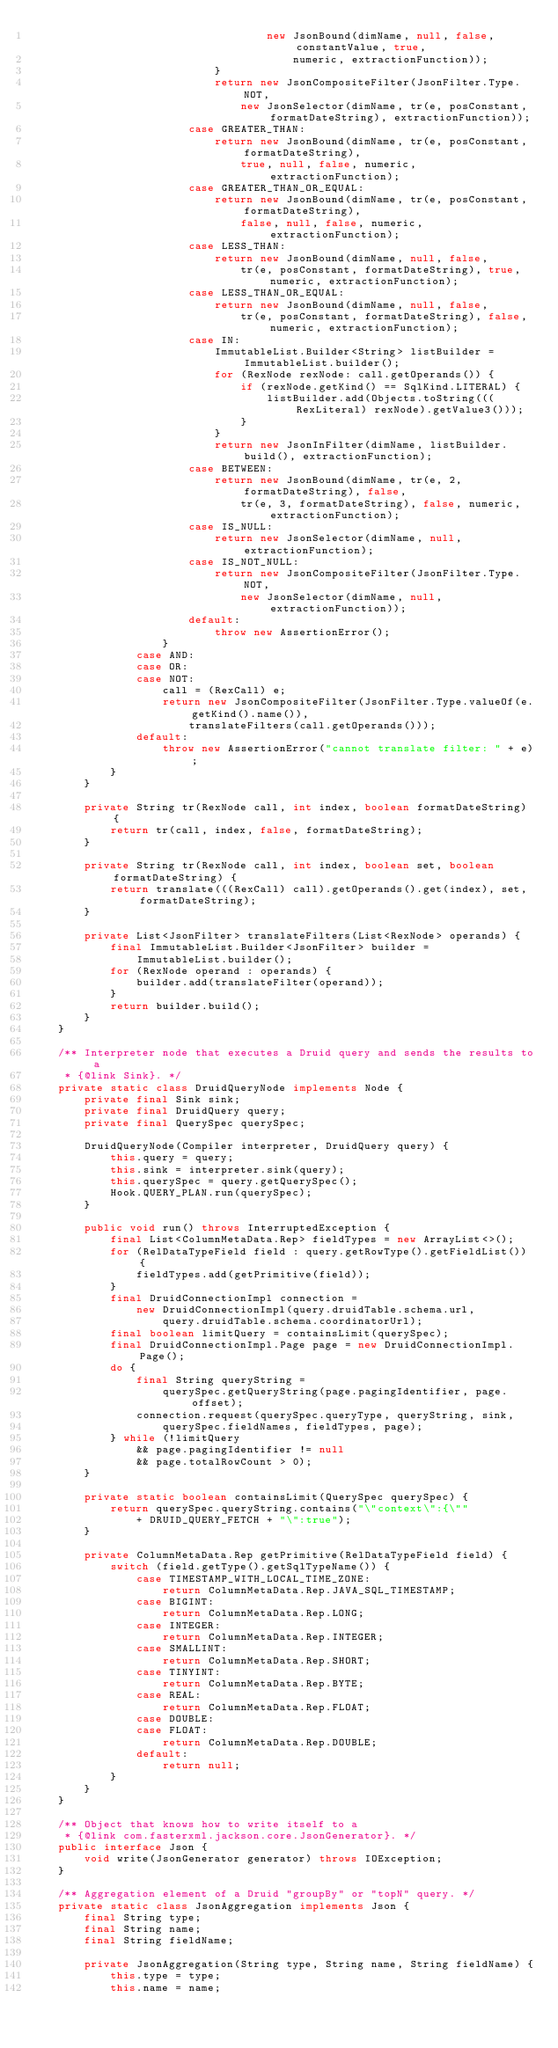<code> <loc_0><loc_0><loc_500><loc_500><_Java_>                                    new JsonBound(dimName, null, false, constantValue, true,
                                        numeric, extractionFunction));
                            }
                            return new JsonCompositeFilter(JsonFilter.Type.NOT,
                                new JsonSelector(dimName, tr(e, posConstant, formatDateString), extractionFunction));
                        case GREATER_THAN:
                            return new JsonBound(dimName, tr(e, posConstant, formatDateString),
                                true, null, false, numeric, extractionFunction);
                        case GREATER_THAN_OR_EQUAL:
                            return new JsonBound(dimName, tr(e, posConstant, formatDateString),
                                false, null, false, numeric, extractionFunction);
                        case LESS_THAN:
                            return new JsonBound(dimName, null, false,
                                tr(e, posConstant, formatDateString), true, numeric, extractionFunction);
                        case LESS_THAN_OR_EQUAL:
                            return new JsonBound(dimName, null, false,
                                tr(e, posConstant, formatDateString), false, numeric, extractionFunction);
                        case IN:
                            ImmutableList.Builder<String> listBuilder = ImmutableList.builder();
                            for (RexNode rexNode: call.getOperands()) {
                                if (rexNode.getKind() == SqlKind.LITERAL) {
                                    listBuilder.add(Objects.toString(((RexLiteral) rexNode).getValue3()));
                                }
                            }
                            return new JsonInFilter(dimName, listBuilder.build(), extractionFunction);
                        case BETWEEN:
                            return new JsonBound(dimName, tr(e, 2, formatDateString), false,
                                tr(e, 3, formatDateString), false, numeric, extractionFunction);
                        case IS_NULL:
                            return new JsonSelector(dimName, null, extractionFunction);
                        case IS_NOT_NULL:
                            return new JsonCompositeFilter(JsonFilter.Type.NOT,
                                new JsonSelector(dimName, null, extractionFunction));
                        default:
                            throw new AssertionError();
                    }
                case AND:
                case OR:
                case NOT:
                    call = (RexCall) e;
                    return new JsonCompositeFilter(JsonFilter.Type.valueOf(e.getKind().name()),
                        translateFilters(call.getOperands()));
                default:
                    throw new AssertionError("cannot translate filter: " + e);
            }
        }

        private String tr(RexNode call, int index, boolean formatDateString) {
            return tr(call, index, false, formatDateString);
        }

        private String tr(RexNode call, int index, boolean set, boolean formatDateString) {
            return translate(((RexCall) call).getOperands().get(index), set, formatDateString);
        }

        private List<JsonFilter> translateFilters(List<RexNode> operands) {
            final ImmutableList.Builder<JsonFilter> builder =
                ImmutableList.builder();
            for (RexNode operand : operands) {
                builder.add(translateFilter(operand));
            }
            return builder.build();
        }
    }

    /** Interpreter node that executes a Druid query and sends the results to a
     * {@link Sink}. */
    private static class DruidQueryNode implements Node {
        private final Sink sink;
        private final DruidQuery query;
        private final QuerySpec querySpec;

        DruidQueryNode(Compiler interpreter, DruidQuery query) {
            this.query = query;
            this.sink = interpreter.sink(query);
            this.querySpec = query.getQuerySpec();
            Hook.QUERY_PLAN.run(querySpec);
        }

        public void run() throws InterruptedException {
            final List<ColumnMetaData.Rep> fieldTypes = new ArrayList<>();
            for (RelDataTypeField field : query.getRowType().getFieldList()) {
                fieldTypes.add(getPrimitive(field));
            }
            final DruidConnectionImpl connection =
                new DruidConnectionImpl(query.druidTable.schema.url,
                    query.druidTable.schema.coordinatorUrl);
            final boolean limitQuery = containsLimit(querySpec);
            final DruidConnectionImpl.Page page = new DruidConnectionImpl.Page();
            do {
                final String queryString =
                    querySpec.getQueryString(page.pagingIdentifier, page.offset);
                connection.request(querySpec.queryType, queryString, sink,
                    querySpec.fieldNames, fieldTypes, page);
            } while (!limitQuery
                && page.pagingIdentifier != null
                && page.totalRowCount > 0);
        }

        private static boolean containsLimit(QuerySpec querySpec) {
            return querySpec.queryString.contains("\"context\":{\""
                + DRUID_QUERY_FETCH + "\":true");
        }

        private ColumnMetaData.Rep getPrimitive(RelDataTypeField field) {
            switch (field.getType().getSqlTypeName()) {
                case TIMESTAMP_WITH_LOCAL_TIME_ZONE:
                    return ColumnMetaData.Rep.JAVA_SQL_TIMESTAMP;
                case BIGINT:
                    return ColumnMetaData.Rep.LONG;
                case INTEGER:
                    return ColumnMetaData.Rep.INTEGER;
                case SMALLINT:
                    return ColumnMetaData.Rep.SHORT;
                case TINYINT:
                    return ColumnMetaData.Rep.BYTE;
                case REAL:
                    return ColumnMetaData.Rep.FLOAT;
                case DOUBLE:
                case FLOAT:
                    return ColumnMetaData.Rep.DOUBLE;
                default:
                    return null;
            }
        }
    }

    /** Object that knows how to write itself to a
     * {@link com.fasterxml.jackson.core.JsonGenerator}. */
    public interface Json {
        void write(JsonGenerator generator) throws IOException;
    }

    /** Aggregation element of a Druid "groupBy" or "topN" query. */
    private static class JsonAggregation implements Json {
        final String type;
        final String name;
        final String fieldName;

        private JsonAggregation(String type, String name, String fieldName) {
            this.type = type;
            this.name = name;</code> 